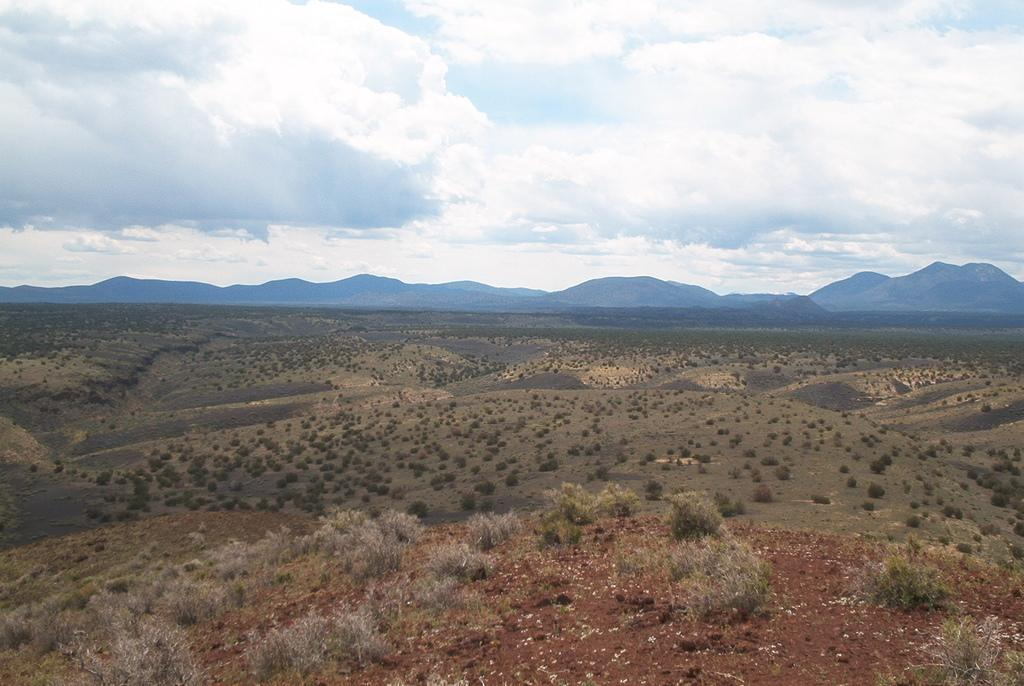What is the main feature in the center of the image? There are mountains, trees, and grass in the center of the image. Can you describe the vegetation in the center of the image? Trees and grass are present in the center of the image. What is visible at the bottom of the image? Plants and the ground are visible at the bottom of the image. What can be seen in the sky at the top of the image? Clouds are present in the sky at the top of the image. What type of bean is growing at the border of the image? There is no bean present in the image, and therefore no such growth can be observed. 